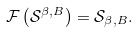<formula> <loc_0><loc_0><loc_500><loc_500>\mathcal { F } \left ( { \mathcal { S } ^ { \beta , B } } \right ) = \mathcal { S } _ { \beta , B } .</formula> 